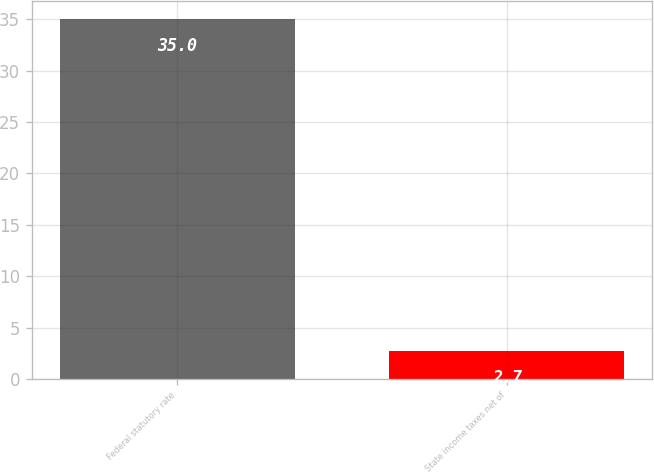Convert chart to OTSL. <chart><loc_0><loc_0><loc_500><loc_500><bar_chart><fcel>Federal statutory rate<fcel>State income taxes net of<nl><fcel>35<fcel>2.7<nl></chart> 